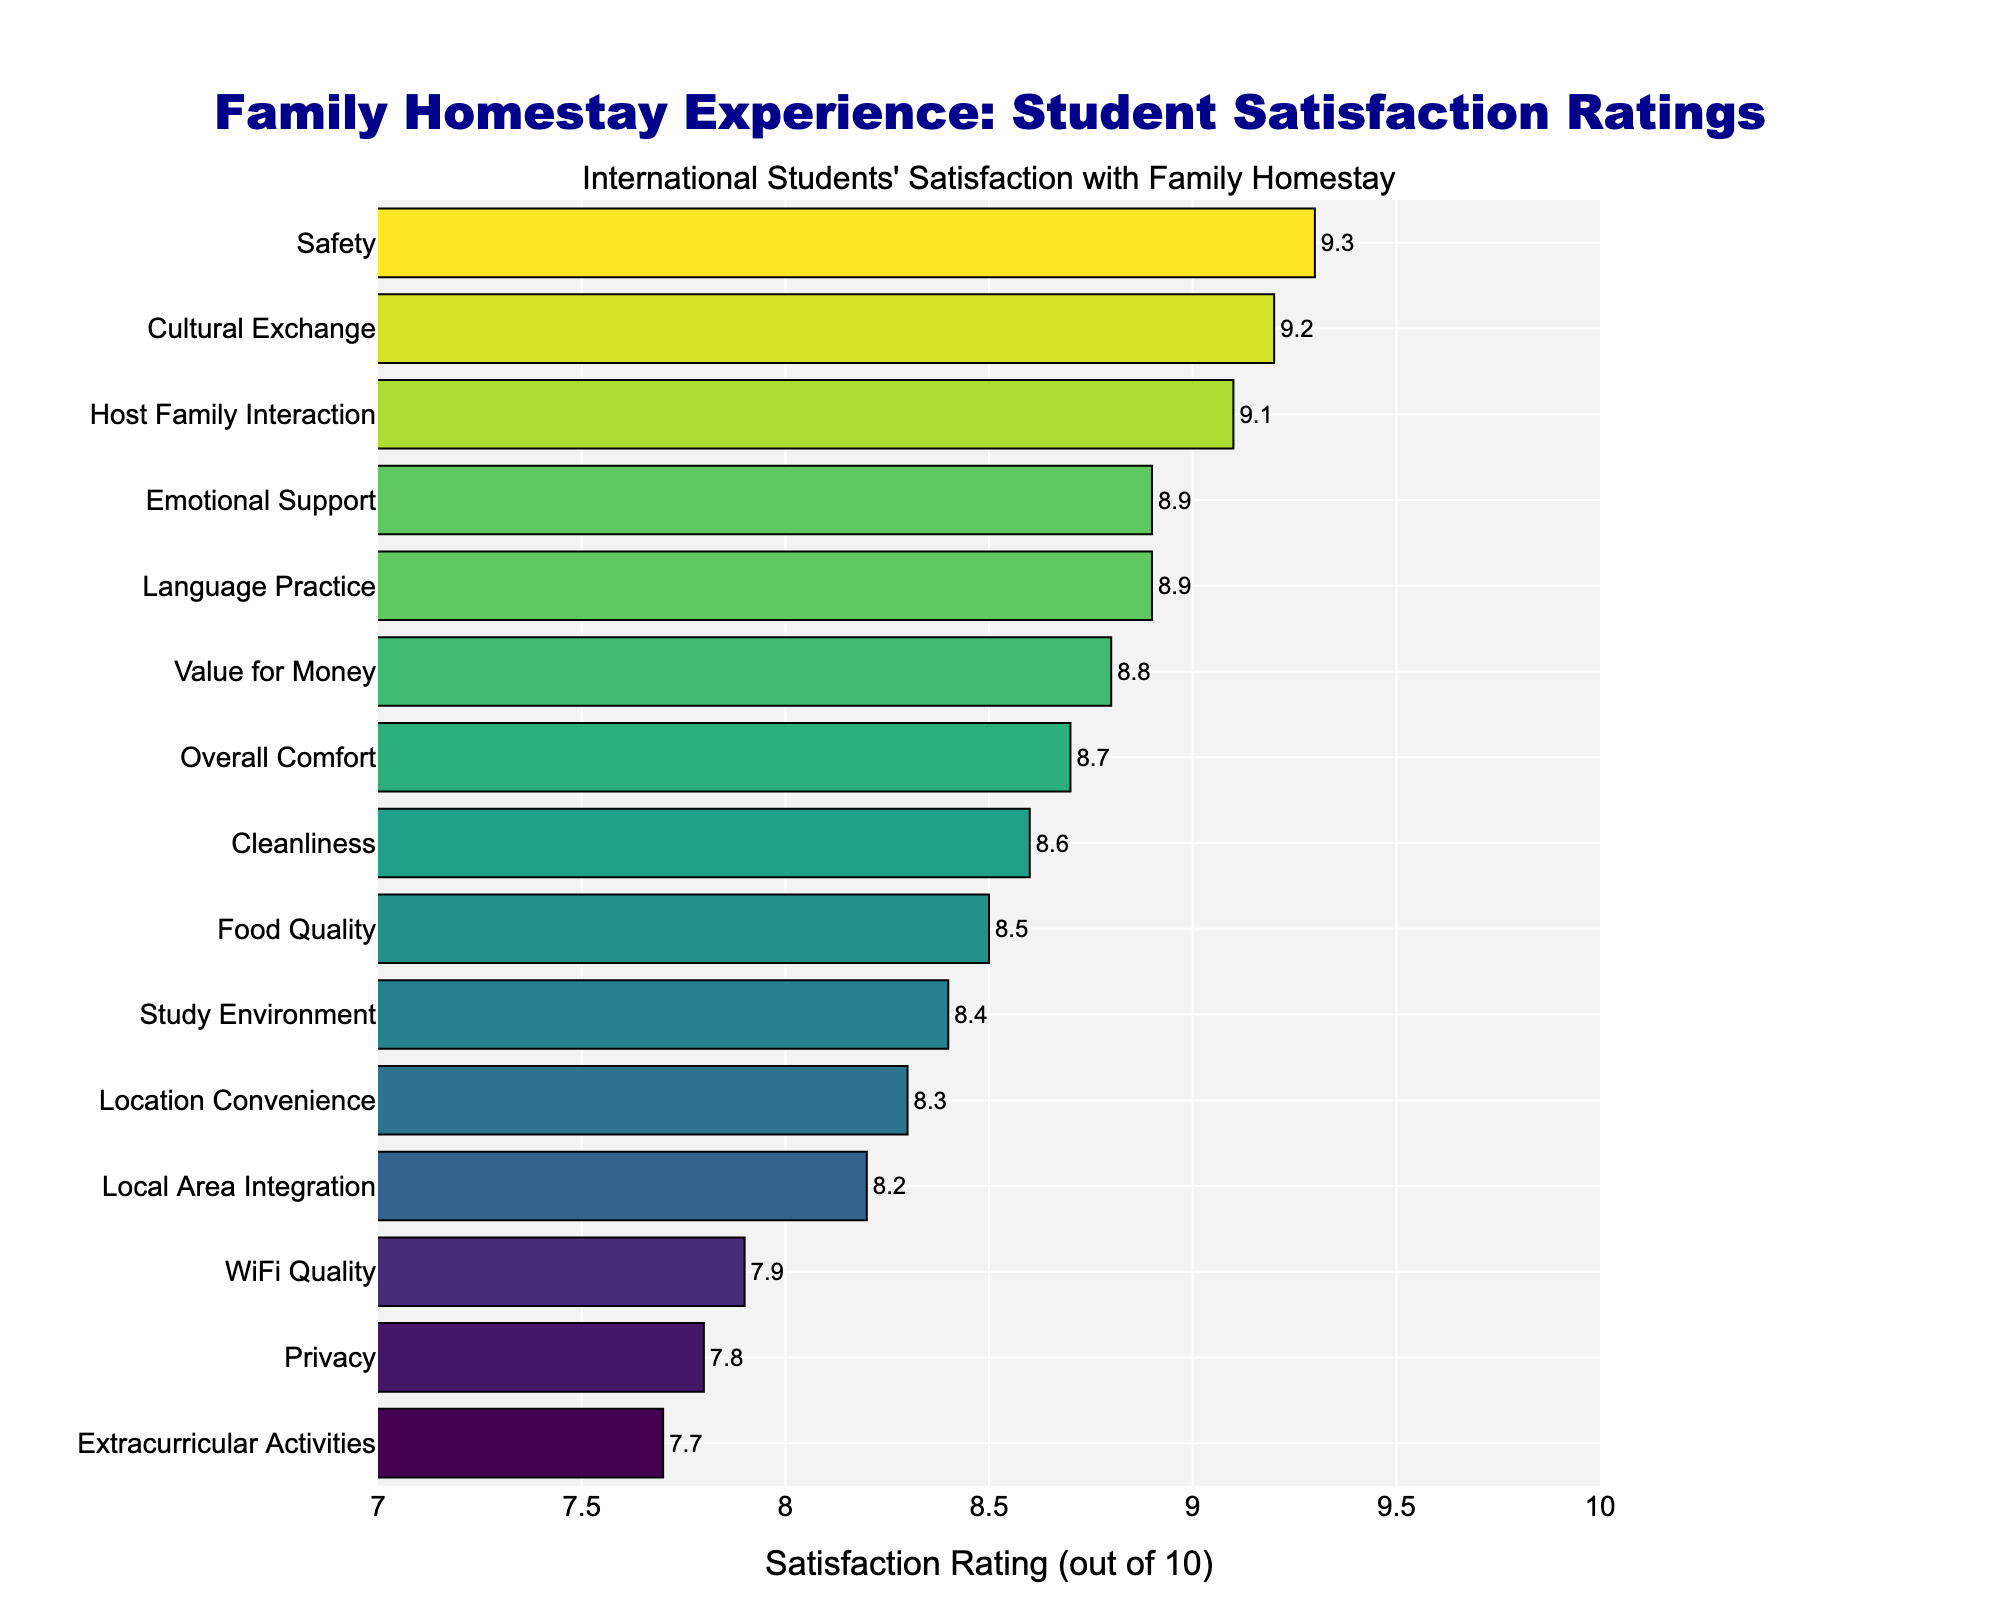Which aspect has the highest satisfaction rating? The bar with the highest length represents the highest satisfaction rating. In this chart, the longest bar is for "Safety" with a rating of 9.3.
Answer: Safety Which two aspects have ratings exactly equal to 8.9? By looking at the bars with "8.9" labels, we observe that "Language Practice" and "Emotional Support" both have ratings of 8.9.
Answer: Language Practice and Emotional Support Is the satisfaction for WiFi Quality higher or lower than Food Quality? Compare the lengths and positions of the bars for "WiFi Quality" and "Food Quality". WiFi has a rating of 7.9, while Food Quality has a rating of 8.5, so WiFi Quality is lower.
Answer: Lower What is the difference between the highest and lowest satisfaction ratings? The highest rating is 9.3 (Safety) and the lowest is 7.7 (Extracurricular Activities). Calculate 9.3 - 7.7.
Answer: 1.6 Are there more aspects with ratings above 9 or below 8? Count the number of bars above 9 and below 8. Above 9: Cultural Exchange, Host Family Interaction, Safety (3). Below 8: Extracurricular Activities, Privacy, WiFi Quality (3).
Answer: Equal What rating does the Location Convenience aspect have? Check the label next to the bar corresponding to "Location Convenience". It is marked as 8.3.
Answer: 8.3 Among Host Family Interaction, Privacy, and Cleanliness, which has the highest rating? Compare the lengths of bars for Host Family Interaction (9.1), Privacy (7.8), and Cleanliness (8.6). The highest rating is for Host Family Interaction.
Answer: Host Family Interaction How does the satisfaction with Food Quality compare to Overall Comfort? Compare the bar lengths for Food Quality (8.5) and Overall Comfort (8.7). Overall Comfort has a higher rating.
Answer: Overall Comfort is higher What is the average satisfaction rating of Cultural Exchange and Study Environment? Sum the ratings of Cultural Exchange (9.2) and Study Environment (8.4), then divide by 2. (9.2 + 8.4) / 2 = 8.8.
Answer: 8.8 Which aspects have a rating that falls within the range of 8 to 9? Identify the bars with ratings between 8 and 9: Overall Comfort (8.7), Language Practice (8.9), Food Quality (8.5), Location Convenience (8.3), Cleanliness (8.6), Value for Money (8.8), Study Environment (8.4), Local Area Integration (8.2).
Answer: Overall Comfort, Language Practice, Food Quality, Location Convenience, Cleanliness, Value for Money, Study Environment, Local Area Integration 